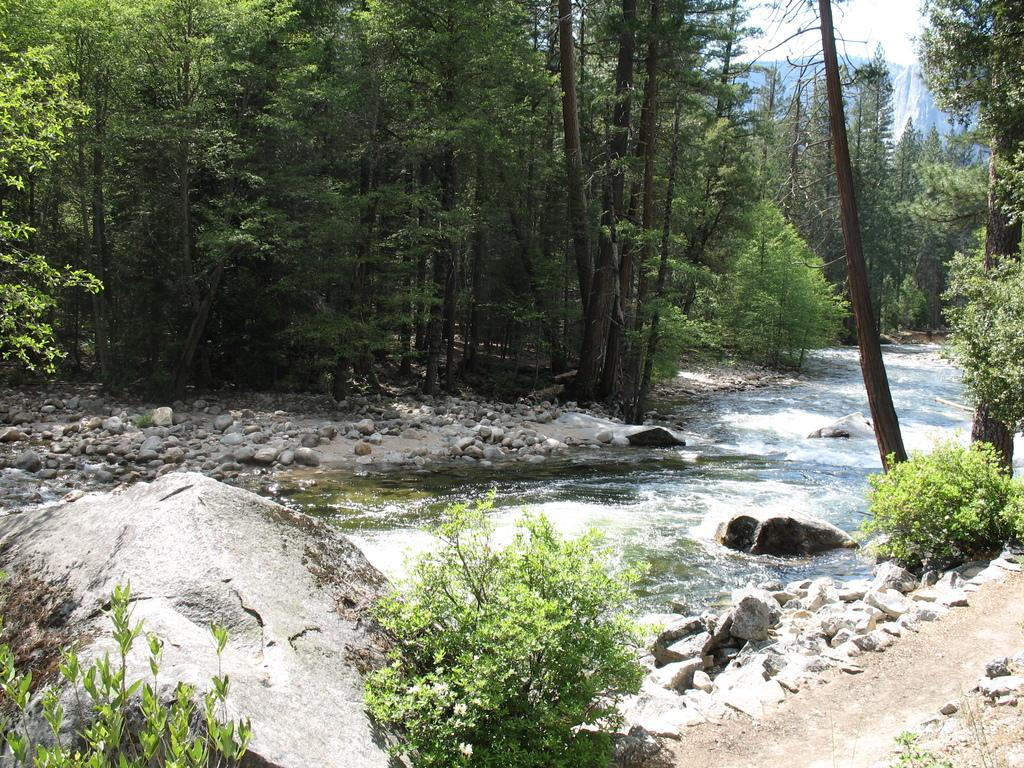What type of vegetation is at the bottom of the image? There are plants at the bottom of the image. What natural feature is in the middle of the image? There is a river in the middle of the image. What can be seen in the river? There are stones present in the river. What type of vegetation is visible in the background of the image? There are trees in the background of the image. What type of grain can be seen being loaded onto a ship at the harbor in the image? There is no harbor or grain present in the image; it features plants, a river, stones, and trees. What route is depicted in the image? There is no route depicted in the image; it shows a river, plants, stones, and trees. 